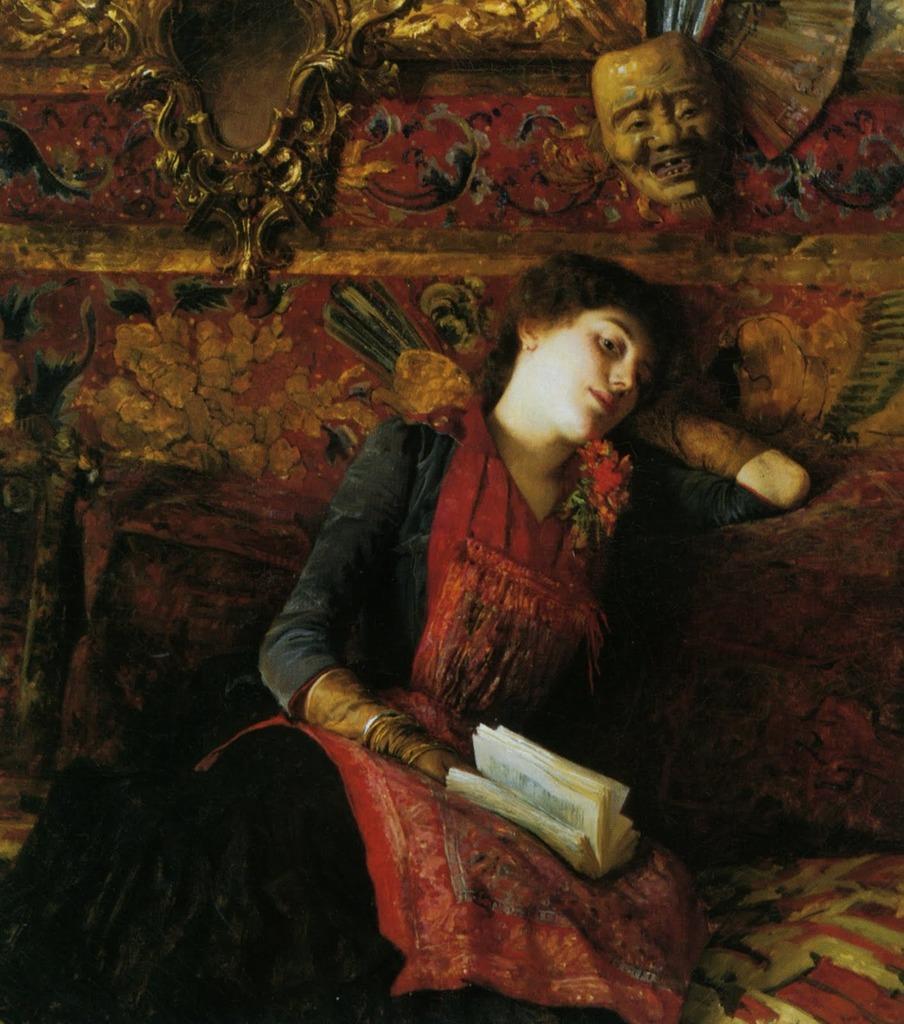In one or two sentences, can you explain what this image depicts? This picture shows a sofa set and a woman seated on it by holding a book in her hand 